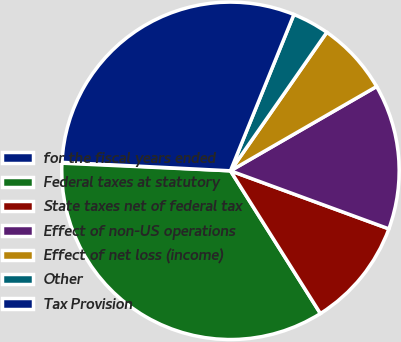Convert chart to OTSL. <chart><loc_0><loc_0><loc_500><loc_500><pie_chart><fcel>for the fiscal years ended<fcel>Federal taxes at statutory<fcel>State taxes net of federal tax<fcel>Effect of non-US operations<fcel>Effect of net loss (income)<fcel>Other<fcel>Tax Provision<nl><fcel>0.08%<fcel>34.68%<fcel>10.46%<fcel>13.92%<fcel>7.0%<fcel>3.54%<fcel>30.34%<nl></chart> 